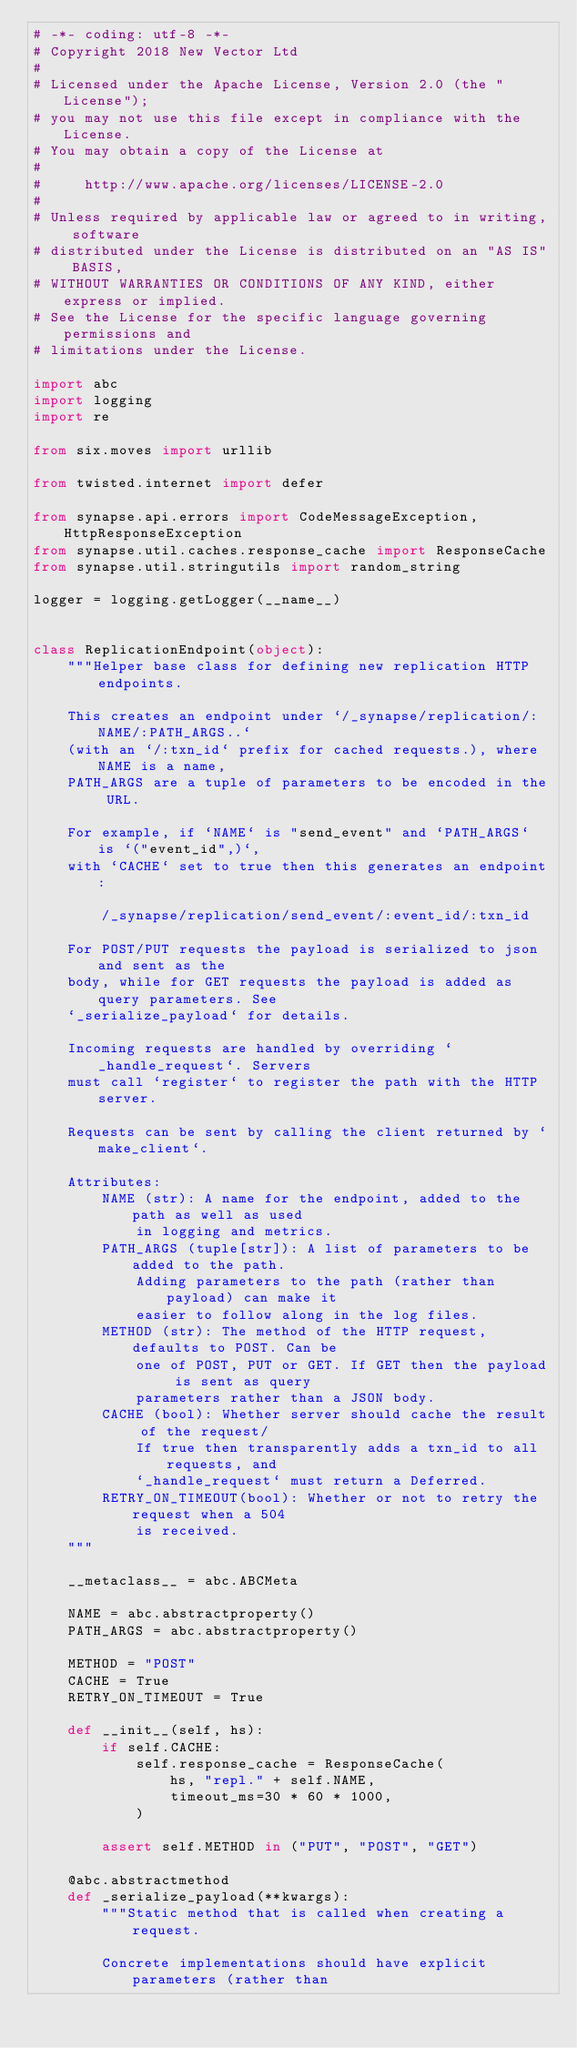<code> <loc_0><loc_0><loc_500><loc_500><_Python_># -*- coding: utf-8 -*-
# Copyright 2018 New Vector Ltd
#
# Licensed under the Apache License, Version 2.0 (the "License");
# you may not use this file except in compliance with the License.
# You may obtain a copy of the License at
#
#     http://www.apache.org/licenses/LICENSE-2.0
#
# Unless required by applicable law or agreed to in writing, software
# distributed under the License is distributed on an "AS IS" BASIS,
# WITHOUT WARRANTIES OR CONDITIONS OF ANY KIND, either express or implied.
# See the License for the specific language governing permissions and
# limitations under the License.

import abc
import logging
import re

from six.moves import urllib

from twisted.internet import defer

from synapse.api.errors import CodeMessageException, HttpResponseException
from synapse.util.caches.response_cache import ResponseCache
from synapse.util.stringutils import random_string

logger = logging.getLogger(__name__)


class ReplicationEndpoint(object):
    """Helper base class for defining new replication HTTP endpoints.

    This creates an endpoint under `/_synapse/replication/:NAME/:PATH_ARGS..`
    (with an `/:txn_id` prefix for cached requests.), where NAME is a name,
    PATH_ARGS are a tuple of parameters to be encoded in the URL.

    For example, if `NAME` is "send_event" and `PATH_ARGS` is `("event_id",)`,
    with `CACHE` set to true then this generates an endpoint:

        /_synapse/replication/send_event/:event_id/:txn_id

    For POST/PUT requests the payload is serialized to json and sent as the
    body, while for GET requests the payload is added as query parameters. See
    `_serialize_payload` for details.

    Incoming requests are handled by overriding `_handle_request`. Servers
    must call `register` to register the path with the HTTP server.

    Requests can be sent by calling the client returned by `make_client`.

    Attributes:
        NAME (str): A name for the endpoint, added to the path as well as used
            in logging and metrics.
        PATH_ARGS (tuple[str]): A list of parameters to be added to the path.
            Adding parameters to the path (rather than payload) can make it
            easier to follow along in the log files.
        METHOD (str): The method of the HTTP request, defaults to POST. Can be
            one of POST, PUT or GET. If GET then the payload is sent as query
            parameters rather than a JSON body.
        CACHE (bool): Whether server should cache the result of the request/
            If true then transparently adds a txn_id to all requests, and
            `_handle_request` must return a Deferred.
        RETRY_ON_TIMEOUT(bool): Whether or not to retry the request when a 504
            is received.
    """

    __metaclass__ = abc.ABCMeta

    NAME = abc.abstractproperty()
    PATH_ARGS = abc.abstractproperty()

    METHOD = "POST"
    CACHE = True
    RETRY_ON_TIMEOUT = True

    def __init__(self, hs):
        if self.CACHE:
            self.response_cache = ResponseCache(
                hs, "repl." + self.NAME,
                timeout_ms=30 * 60 * 1000,
            )

        assert self.METHOD in ("PUT", "POST", "GET")

    @abc.abstractmethod
    def _serialize_payload(**kwargs):
        """Static method that is called when creating a request.

        Concrete implementations should have explicit parameters (rather than</code> 